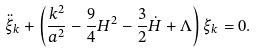<formula> <loc_0><loc_0><loc_500><loc_500>\ddot { \xi } _ { k } + \left ( \frac { k ^ { 2 } } { a ^ { 2 } } - \frac { 9 } { 4 } H ^ { 2 } - \frac { 3 } { 2 } \dot { H } + \Lambda \right ) \xi _ { k } = 0 .</formula> 